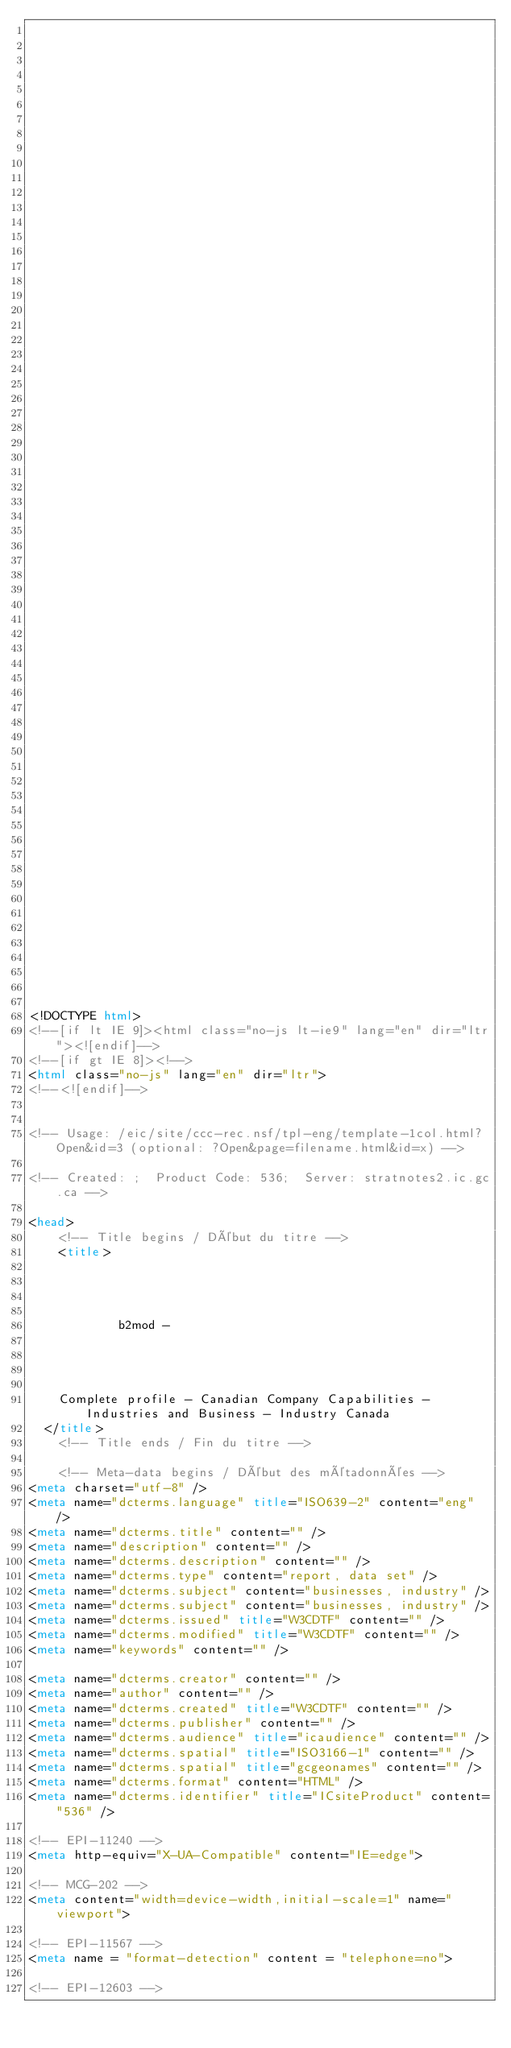<code> <loc_0><loc_0><loc_500><loc_500><_HTML_>


















	






  
  
  
  































	
	
	



<!DOCTYPE html>
<!--[if lt IE 9]><html class="no-js lt-ie9" lang="en" dir="ltr"><![endif]-->
<!--[if gt IE 8]><!-->
<html class="no-js" lang="en" dir="ltr">
<!--<![endif]-->


<!-- Usage: /eic/site/ccc-rec.nsf/tpl-eng/template-1col.html?Open&id=3 (optional: ?Open&page=filename.html&id=x) -->

<!-- Created: ;  Product Code: 536;  Server: stratnotes2.ic.gc.ca -->

<head>
	<!-- Title begins / Début du titre -->
	<title>
    
            
        
          
            b2mod -
          
        
      
    
    Complete profile - Canadian Company Capabilities - Industries and Business - Industry Canada
  </title>
	<!-- Title ends / Fin du titre -->
 
	<!-- Meta-data begins / Début des métadonnées -->
<meta charset="utf-8" />
<meta name="dcterms.language" title="ISO639-2" content="eng" />
<meta name="dcterms.title" content="" />
<meta name="description" content="" />
<meta name="dcterms.description" content="" />
<meta name="dcterms.type" content="report, data set" />
<meta name="dcterms.subject" content="businesses, industry" />
<meta name="dcterms.subject" content="businesses, industry" />
<meta name="dcterms.issued" title="W3CDTF" content="" />
<meta name="dcterms.modified" title="W3CDTF" content="" />
<meta name="keywords" content="" />

<meta name="dcterms.creator" content="" />
<meta name="author" content="" />
<meta name="dcterms.created" title="W3CDTF" content="" />
<meta name="dcterms.publisher" content="" />
<meta name="dcterms.audience" title="icaudience" content="" />
<meta name="dcterms.spatial" title="ISO3166-1" content="" />
<meta name="dcterms.spatial" title="gcgeonames" content="" />
<meta name="dcterms.format" content="HTML" />
<meta name="dcterms.identifier" title="ICsiteProduct" content="536" />

<!-- EPI-11240 -->
<meta http-equiv="X-UA-Compatible" content="IE=edge">

<!-- MCG-202 -->
<meta content="width=device-width,initial-scale=1" name="viewport">

<!-- EPI-11567 -->
<meta name = "format-detection" content = "telephone=no">

<!-- EPI-12603 --></code> 